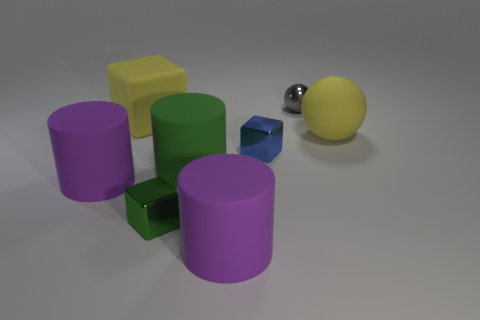How many purple cylinders must be subtracted to get 1 purple cylinders? 1 Add 1 purple matte things. How many objects exist? 9 Subtract all cubes. How many objects are left? 5 Subtract 0 red balls. How many objects are left? 8 Subtract all small gray spheres. Subtract all big rubber cylinders. How many objects are left? 4 Add 7 gray metal balls. How many gray metal balls are left? 8 Add 2 big purple cylinders. How many big purple cylinders exist? 4 